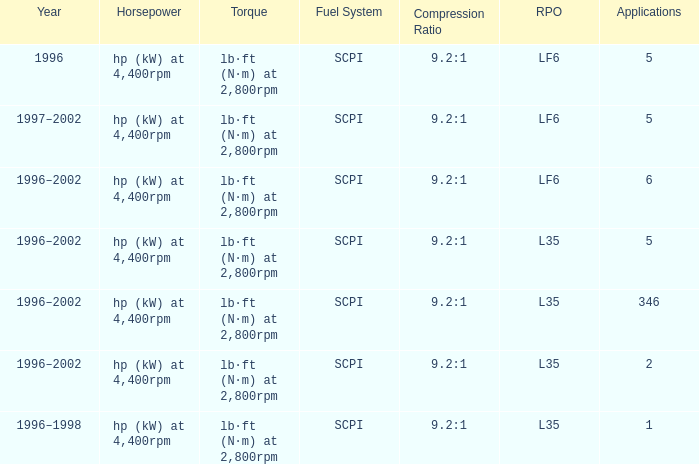What are the torque characteristics of the model made in 1996? Lb·ft (n·m) at 2,800rpm. 